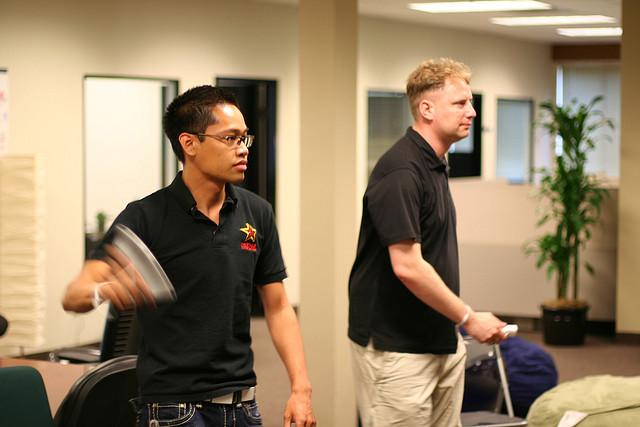What activity are the men involved in? Please explain your reasoning. gaming. The men are holding video game controllers based on the size and design of the objects. people holding video game remotes and regarding something together are likely doing answer a. 